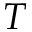<formula> <loc_0><loc_0><loc_500><loc_500>T</formula> 